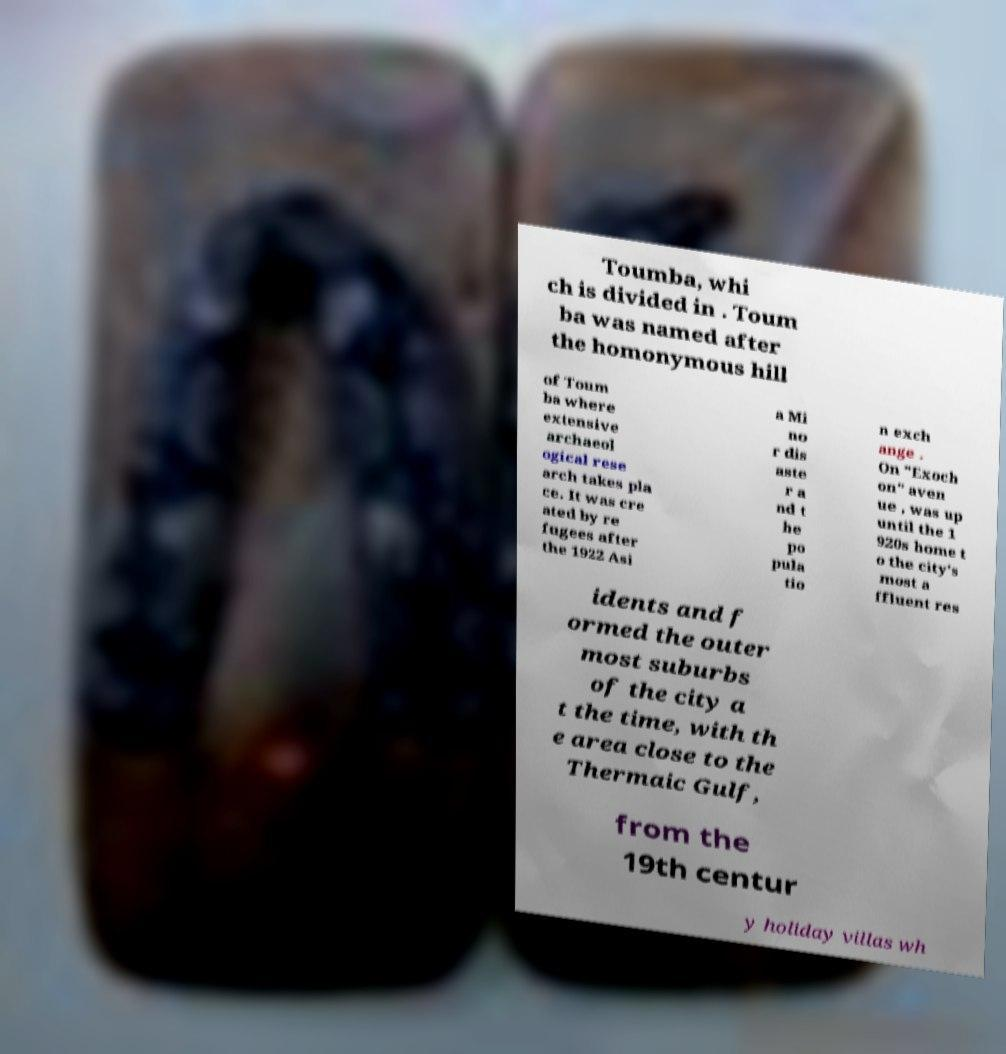Please identify and transcribe the text found in this image. Toumba, whi ch is divided in . Toum ba was named after the homonymous hill of Toum ba where extensive archaeol ogical rese arch takes pla ce. It was cre ated by re fugees after the 1922 Asi a Mi no r dis aste r a nd t he po pula tio n exch ange . On "Exoch on" aven ue , was up until the 1 920s home t o the city's most a ffluent res idents and f ormed the outer most suburbs of the city a t the time, with th e area close to the Thermaic Gulf, from the 19th centur y holiday villas wh 